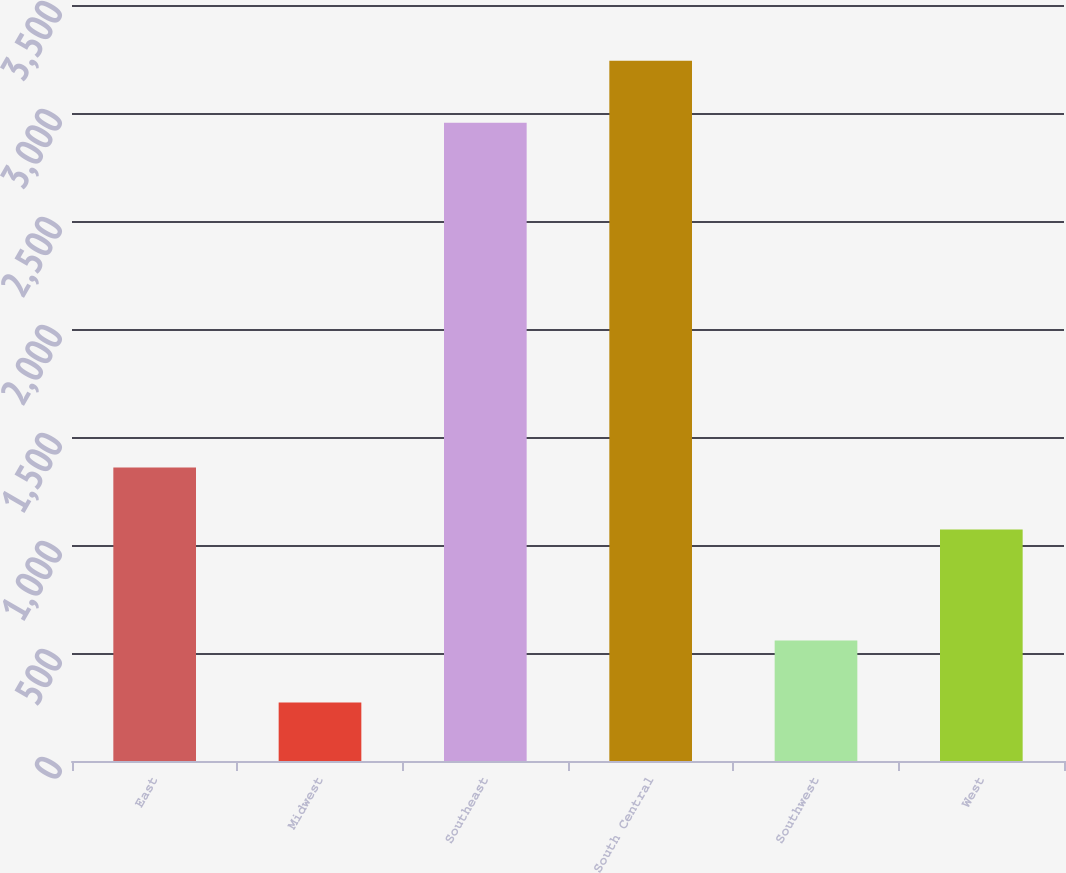Convert chart to OTSL. <chart><loc_0><loc_0><loc_500><loc_500><bar_chart><fcel>East<fcel>Midwest<fcel>Southeast<fcel>South Central<fcel>Southwest<fcel>West<nl><fcel>1358.5<fcel>271<fcel>2955<fcel>3241.5<fcel>557.5<fcel>1072<nl></chart> 